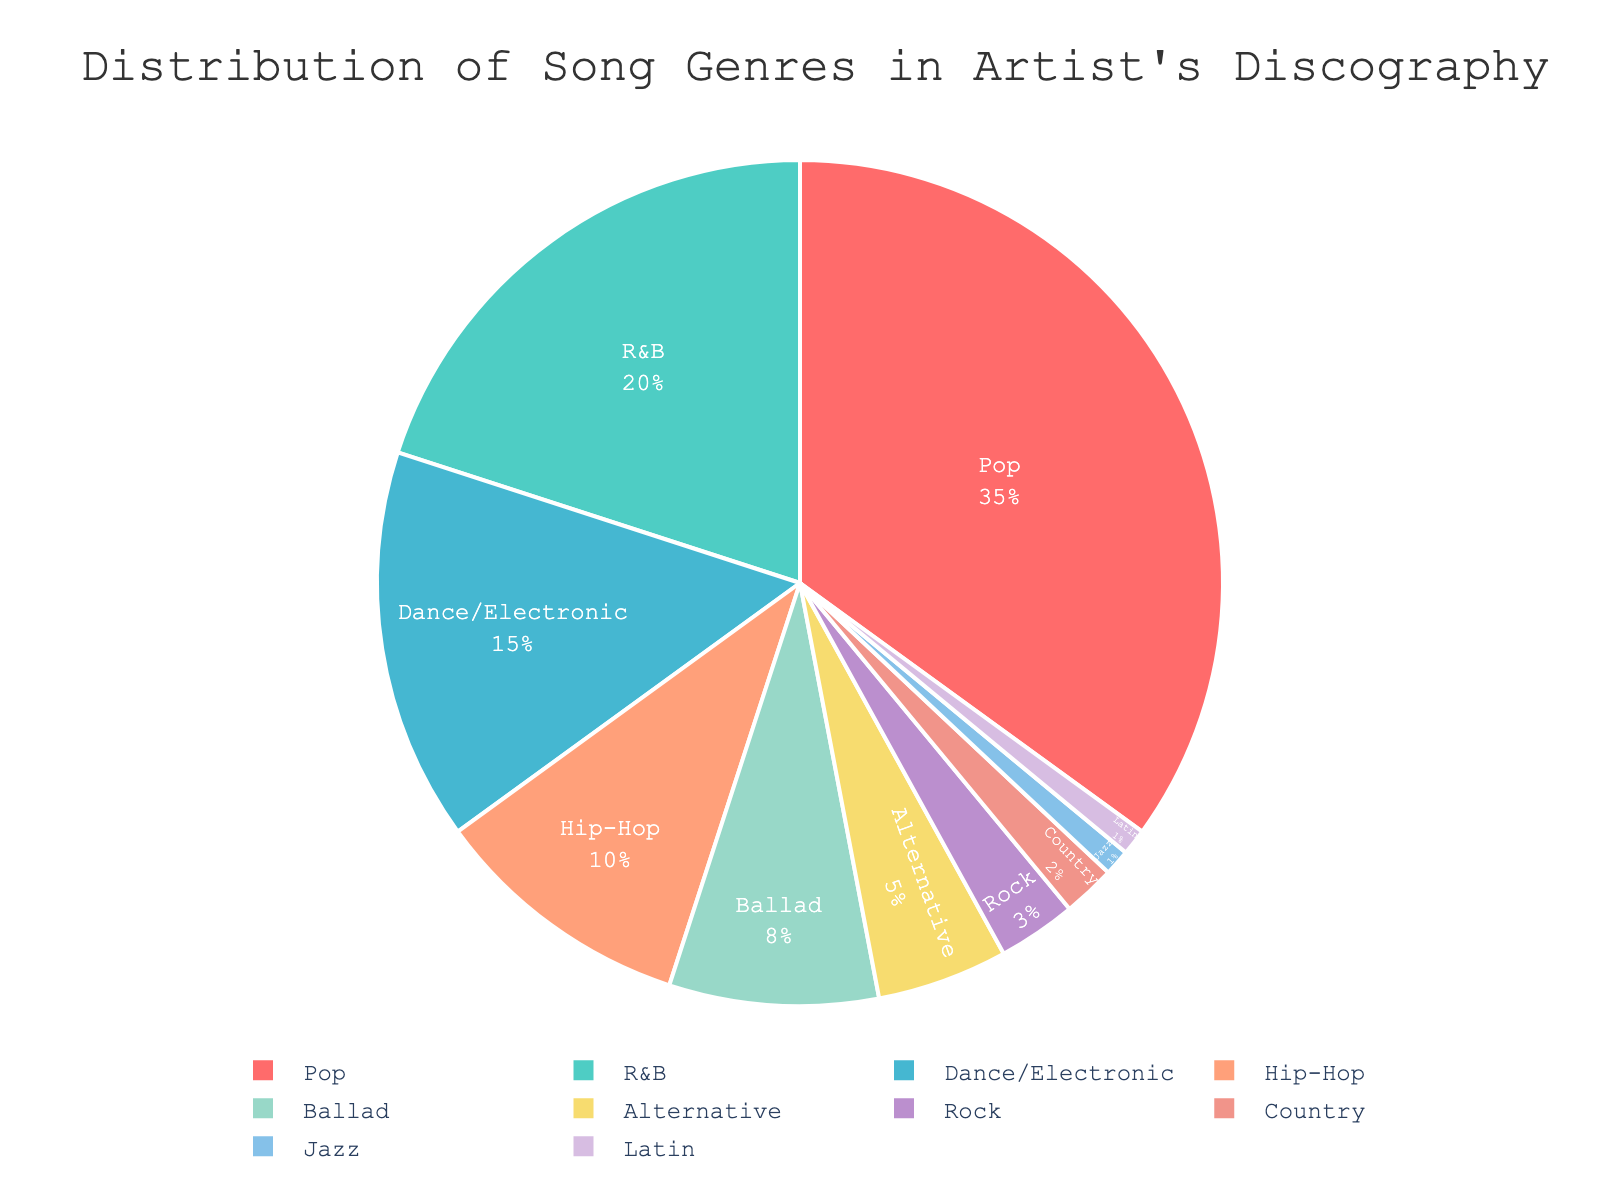What percentage of the artist's discography is made up by Pop songs? Looking at the pie chart, one segment is labeled as Pop and shows it covers 35% of the artist's discography.
Answer: 35% Which genre has the smallest representation in the artist's discography, and what is its percentage? The pie chart indicates that both Jazz and Latin are the smallest segments, each labeled as covering 1% of the artist’s discography.
Answer: Jazz and Latin, 1% How much larger is the Pop genre compared to the Alternative genre? According to the chart, the Pop genre is 35%, and the Alternative genre is 5%. Subtracting these gives 35% - 5% = 30%.
Answer: 30% What is the total percentage of the discography represented by genres that are 10% or less? Summing up the percentages for Hip-Hop (10%), Ballad (8%), Alternative (5%), Rock (3%), Country (2%), Jazz (1%), and Latin (1%) gives 10% + 8% + 5% + 3% + 2% + 1% + 1% = 30%.
Answer: 30% Is the combined percentage of R&B and Dance/Electronic greater than that of Pop? The chart shows R&B at 20% and Dance/Electronic at 15%. Adding these gives 20% + 15% = 35%, which is equal to the percentage of Pop.
Answer: No, it is equal Which genre represented by a segment in a distinctive blue color, and what is its percentage? The pie chart highlights the Dance/Electronic segment in a distinctive blue color. This segment is labeled as covering 15% of the artist's discography.
Answer: Dance/Electronic, 15% List in descending order of their percentages the top three genres from the chart. Referring to the chart segments, Pop is 35%, R&B is 20%, and Dance/Electronic is 15%.
Answer: Pop, R&B, Dance/Electronic What percentage is represented by the sum of Country and Jazz genres? The chart shows Country as 2% and Jazz as 1%. Summing these percentages gives 2% + 1% = 3%.
Answer: 3% Which genre has a higher percentage: Alternative or Hip-Hop, and by how much? The Alternative genre is 5%, while Hip-Hop is 10%. Subtracting these gives 10% - 5% = 5%.
Answer: Hip-Hop, by 5% Identify the genres that collectively make up less than 10% of the discography. The chart segments show that Rock (3%), Country (2%), Jazz (1%), and Latin (1%) each are less than 10%.
Answer: Rock, Country, Jazz, Latin 